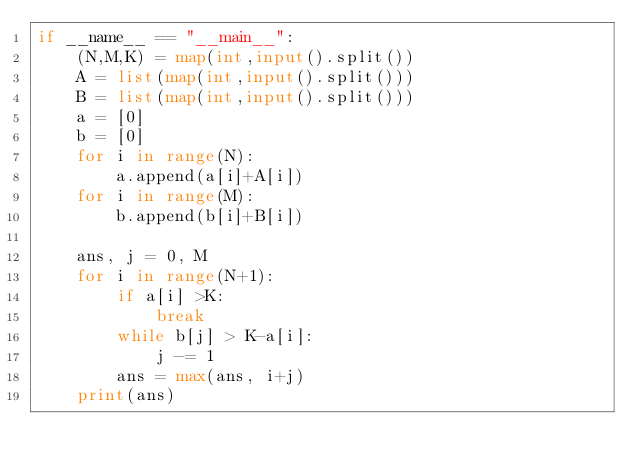<code> <loc_0><loc_0><loc_500><loc_500><_Python_>if __name__ == "__main__":
    (N,M,K) = map(int,input().split())
    A = list(map(int,input().split()))
    B = list(map(int,input().split()))
    a = [0]
    b = [0]
    for i in range(N):
        a.append(a[i]+A[i])
    for i in range(M):
        b.append(b[i]+B[i])

    ans, j = 0, M
    for i in range(N+1):
        if a[i] >K:
            break
        while b[j] > K-a[i]:
            j -= 1
        ans = max(ans, i+j)
    print(ans)</code> 